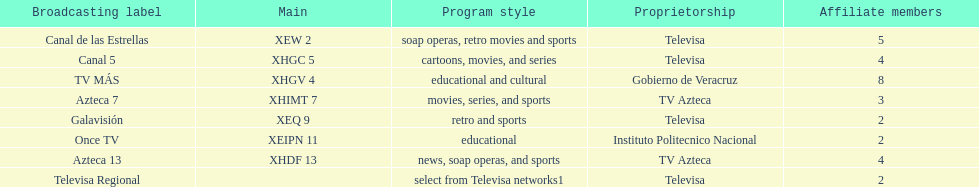How many networks show soap operas? 2. 